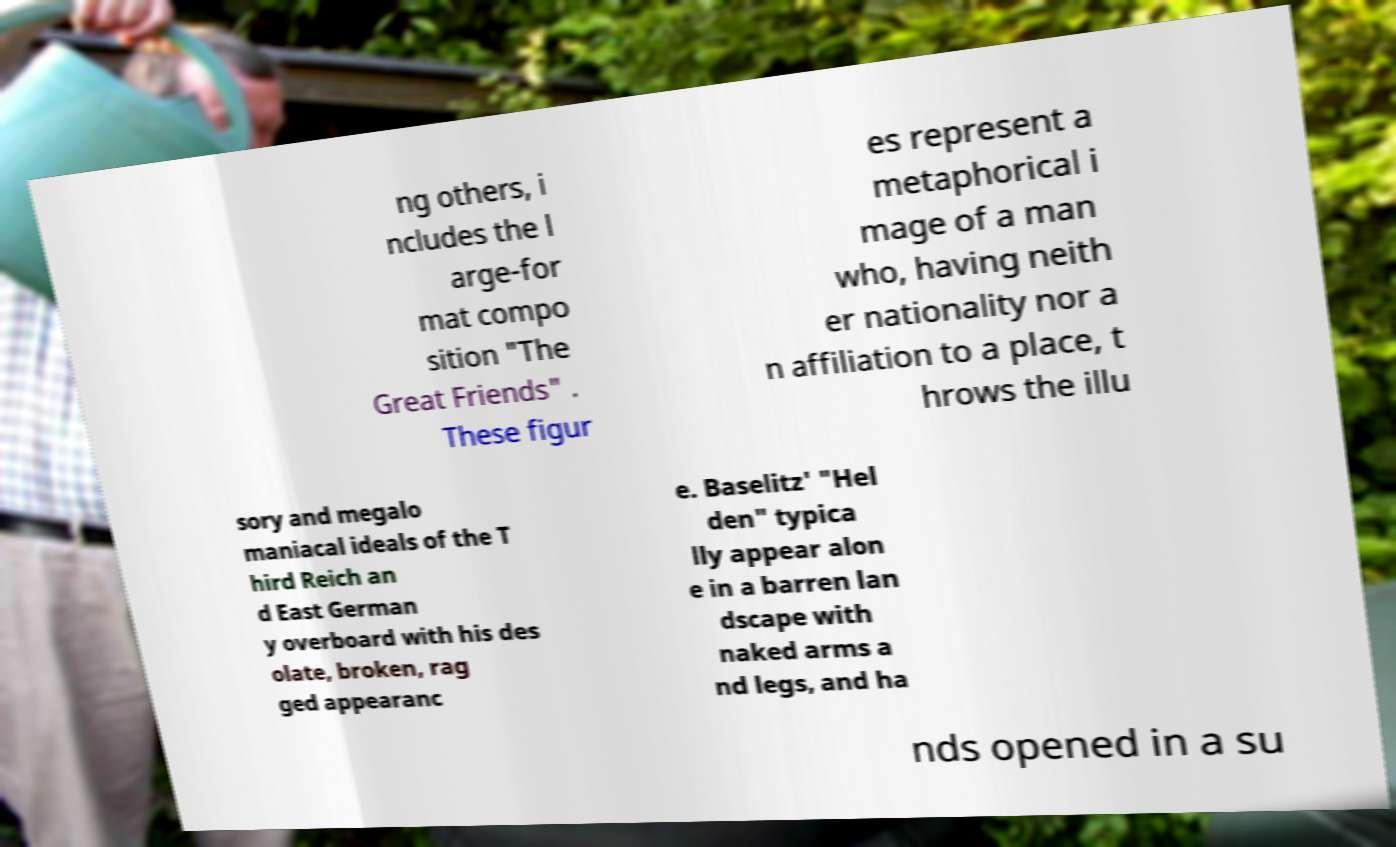There's text embedded in this image that I need extracted. Can you transcribe it verbatim? ng others, i ncludes the l arge-for mat compo sition "The Great Friends" . These figur es represent a metaphorical i mage of a man who, having neith er nationality nor a n affiliation to a place, t hrows the illu sory and megalo maniacal ideals of the T hird Reich an d East German y overboard with his des olate, broken, rag ged appearanc e. Baselitz' "Hel den" typica lly appear alon e in a barren lan dscape with naked arms a nd legs, and ha nds opened in a su 